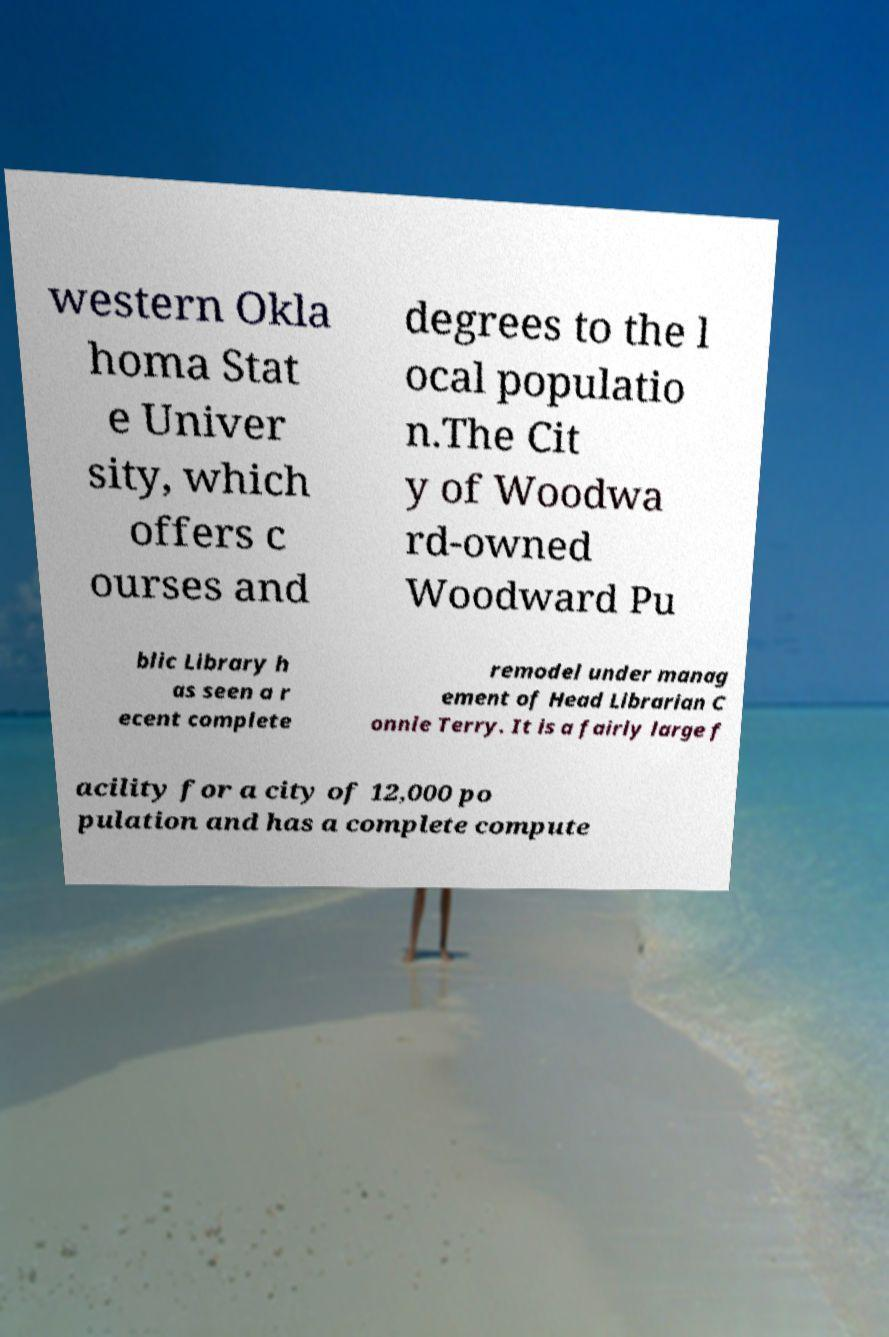Please read and relay the text visible in this image. What does it say? western Okla homa Stat e Univer sity, which offers c ourses and degrees to the l ocal populatio n.The Cit y of Woodwa rd-owned Woodward Pu blic Library h as seen a r ecent complete remodel under manag ement of Head Librarian C onnie Terry. It is a fairly large f acility for a city of 12,000 po pulation and has a complete compute 